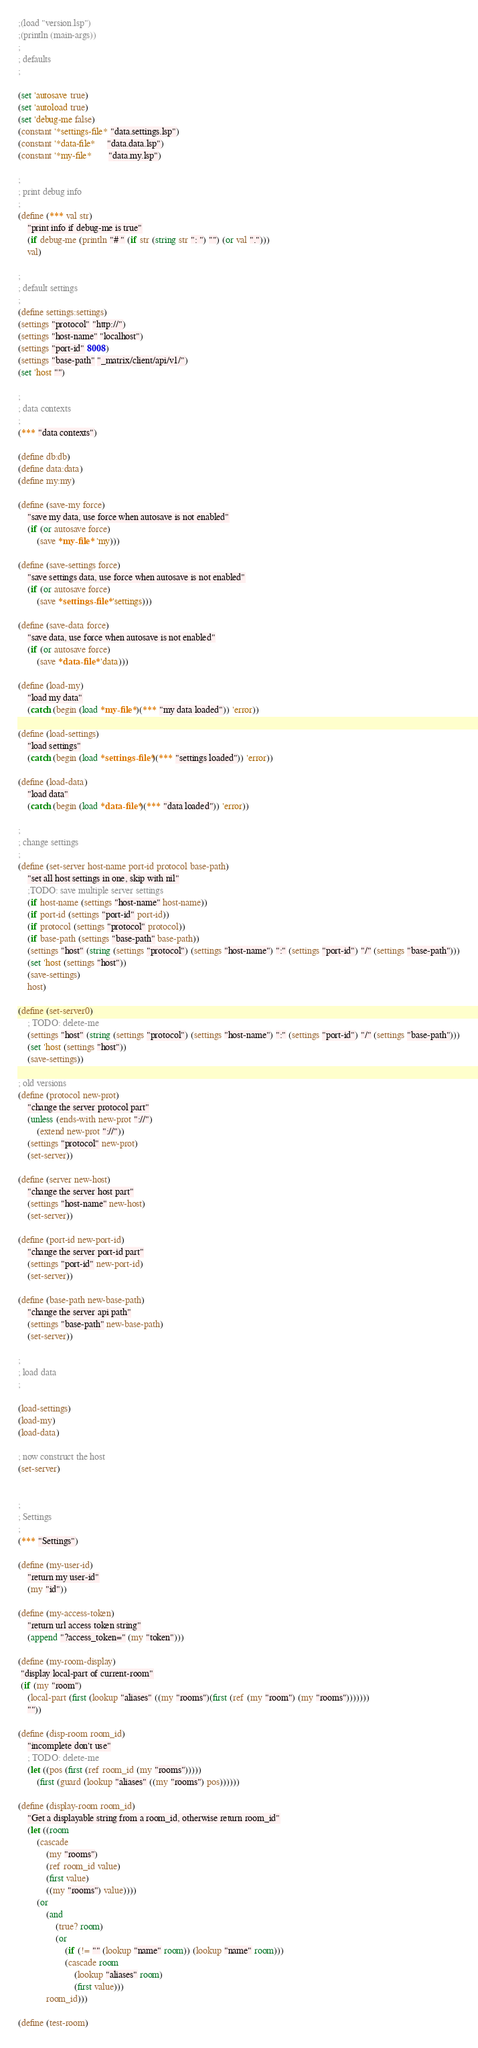<code> <loc_0><loc_0><loc_500><loc_500><_Lisp_>;(load "version.lsp")
;(println (main-args))
;
; defaults
;

(set 'autosave true)
(set 'autoload true)
(set 'debug-me false)
(constant '*settings-file* "data.settings.lsp")
(constant '*data-file*     "data.data.lsp")
(constant '*my-file*       "data.my.lsp")

;
; print debug info
;
(define (*** val str)
	"print info if debug-me is true"
	(if debug-me (println "# " (if str (string str ": ") "") (or val ".")))
	val)

;
; default settings
;
(define settings:settings)
(settings "protocol" "http://")
(settings "host-name" "localhost")
(settings "port-id" 8008)
(settings "base-path" "_matrix/client/api/v1/")
(set 'host "")

;
; data contexts
;
(*** "data contexts")

(define db:db)
(define data:data)
(define my:my)

(define (save-my force)
	"save my data, use force when autosave is not enabled"
	(if (or autosave force)
		(save *my-file* 'my)))

(define (save-settings force)
	"save settings data, use force when autosave is not enabled"
	(if (or autosave force)
		(save *settings-file* 'settings)))

(define (save-data force)
	"save data, use force when autosave is not enabled"
	(if (or autosave force)
		(save *data-file* 'data)))

(define (load-my)
	"load my data"
	(catch (begin (load *my-file*)(*** "my data loaded")) 'error))

(define (load-settings)
	"load settings"
	(catch (begin (load *settings-file*)(*** "settings loaded")) 'error))

(define (load-data)
	"load data"
	(catch (begin (load *data-file*)(*** "data loaded")) 'error))

;
; change settings
;
(define (set-server host-name port-id protocol base-path)
	"set all host settings in one, skip with nil"
	;TODO: save multiple server settings
	(if host-name (settings "host-name" host-name))
	(if port-id (settings "port-id" port-id))
	(if protocol (settings "protocol" protocol))
	(if base-path (settings "base-path" base-path))
	(settings "host" (string (settings "protocol") (settings "host-name") ":" (settings "port-id") "/" (settings "base-path")))
	(set 'host (settings "host"))
	(save-settings)
	host)

(define (set-server0)
	; TODO: delete-me
	(settings "host" (string (settings "protocol") (settings "host-name") ":" (settings "port-id") "/" (settings "base-path")))
	(set 'host (settings "host"))
	(save-settings))

; old versions
(define (protocol new-prot)
	"change the server protocol part"
	(unless (ends-with new-prot "://")
		(extend new-prot "://"))
	(settings "protocol" new-prot)
	(set-server))

(define (server new-host)
	"change the server host part"
	(settings "host-name" new-host)
	(set-server))

(define (port-id new-port-id)
	"change the server port-id part"
	(settings "port-id" new-port-id)
	(set-server))

(define (base-path new-base-path)
	"change the server api path"
	(settings "base-path" new-base-path)
	(set-server))

;
; load data
;

(load-settings)
(load-my)
(load-data)

; now construct the host
(set-server)


;
; Settings
;
(*** "Settings")

(define (my-user-id)
	"return my user-id"
	(my "id"))

(define (my-access-token)
	"return url access token string"
	(append "?access_token=" (my "token")))

(define (my-room-display)
 "display local-part of current-room"
 (if (my "room")
	(local-part (first (lookup "aliases" ((my "rooms")(first (ref (my "room") (my "rooms")))))))
	""))

(define (disp-room room_id)
	"incomplete don't use"
	; TODO: delete-me
	(let ((pos (first (ref room_id (my "rooms")))))
		(first (guard (lookup "aliases" ((my "rooms") pos))))))

(define (display-room room_id)
	"Get a displayable string from a room_id, otherwise return room_id"
	(let ((room 
		(cascade 
			(my "rooms")
			(ref room_id value)
			(first value)
			((my "rooms") value))))
		(or
			(and  
				(true? room) 
				(or 
					(if (!= "" (lookup "name" room)) (lookup "name" room)))
					(cascade room
						(lookup "aliases" room)
						(first value)))
			room_id)))

(define (test-room)</code> 